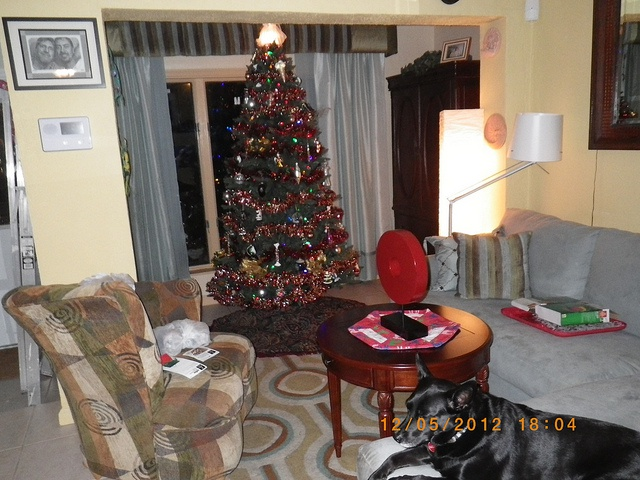Describe the objects in this image and their specific colors. I can see couch in tan, gray, darkgray, and maroon tones, couch in tan, gray, and maroon tones, chair in tan, gray, and darkgray tones, dog in tan, black, gray, orange, and lightgray tones, and couch in tan, lightgray, darkgray, and gray tones in this image. 